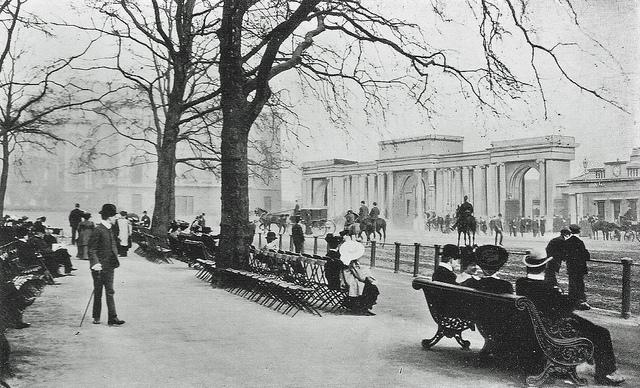What is the man sitting on?
Be succinct. Bench. What is the architectural style of the building behind the people?
Short answer required. Roman. How many benches are there?
Concise answer only. 4. Was this photo taken in 2015?
Keep it brief. No. Is this pic black and white?
Answer briefly. Yes. Was this photo taken recently"?
Be succinct. No. 